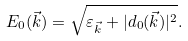Convert formula to latex. <formula><loc_0><loc_0><loc_500><loc_500>E _ { 0 } ( \vec { k } ) = \sqrt { \varepsilon _ { \vec { k } } + | d _ { 0 } ( \vec { k } ) | ^ { 2 } } .</formula> 